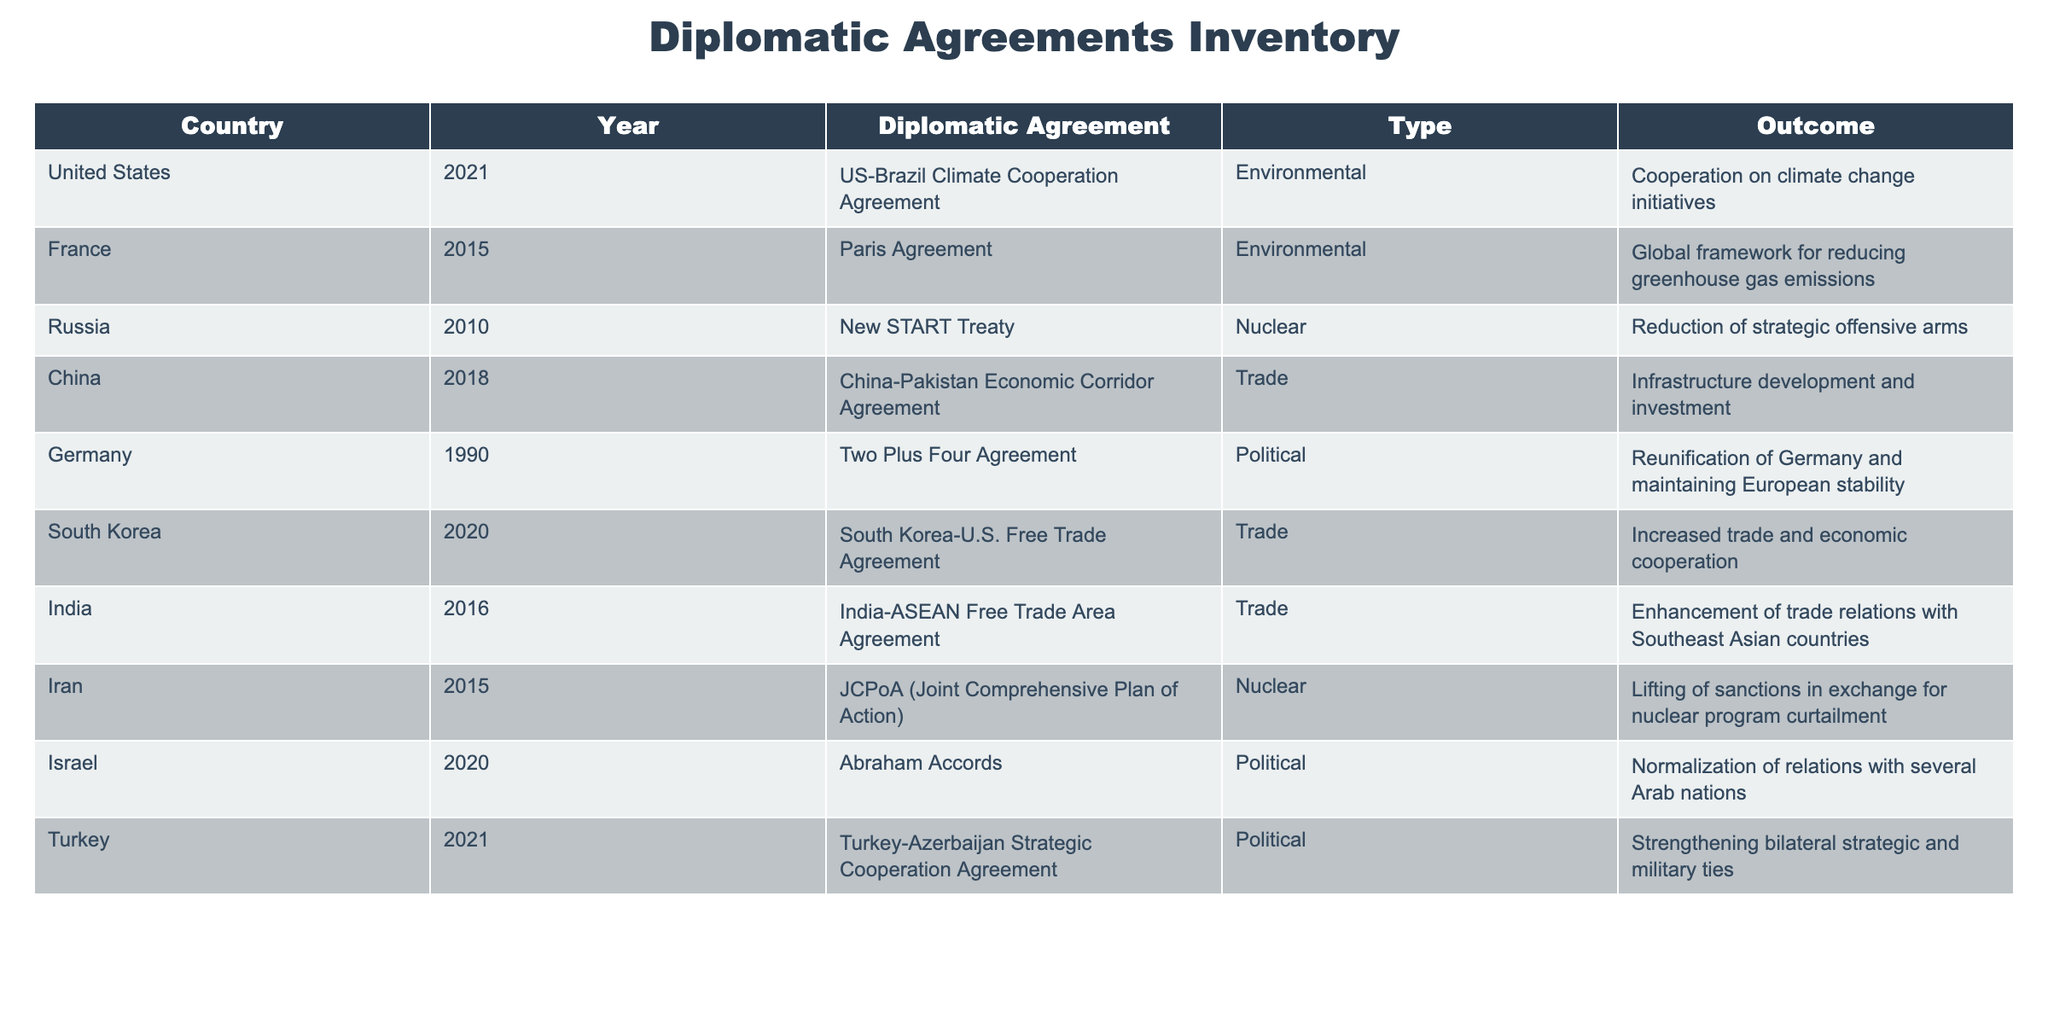What year was the Paris Agreement signed? The Paris Agreement was signed in 2015, as noted in the "Year" column corresponding to "Paris Agreement" listed under "Diplomatic Agreement".
Answer: 2015 Which diplomatic agreement focused on environmental issues and was signed by the United States? The US-Brazil Climate Cooperation Agreement focused on environmental issues and was signed by the United States in 2021.
Answer: US-Brazil Climate Cooperation Agreement How many trade agreements are listed in the table? The table lists three trade agreements: the China-Pakistan Economic Corridor Agreement, South Korea-U.S. Free Trade Agreement, and India-ASEAN Free Trade Area Agreement.
Answer: 3 Did Turkey sign any diplomatic agreement focused on military ties? Yes, Turkey signed the Turkey-Azerbaijan Strategic Cooperation Agreement, which aimed at strengthening bilateral strategic and military ties.
Answer: Yes What was the outcome of the Iran nuclear agreement? The outcome of the JCPoA (Joint Comprehensive Plan of Action) was the lifting of sanctions in exchange for curtailment of Iran's nuclear program, as stated in the outcome column.
Answer: Lifting of sanctions Which country signed a political agreement in 2020 that involved normalization of relations with Arab nations? Israel signed the Abraham Accords in 2020, which involved normalization of relations with several Arab nations.
Answer: Israel How many years elapsed between the two Plus Four Agreement and the New START Treaty? The Two Plus Four Agreement was signed in 1990 and the New START Treaty in 2010. Therefore, 2010 - 1990 = 20 years elapsed between these two agreements.
Answer: 20 years How many nuclear agreements are present in the table? There are two nuclear agreements in the table: the New START Treaty (2010) and the JCPoA (2015).
Answer: 2 Which country had the earliest diplomatic agreement listed in the table? The earliest diplomatic agreement listed is the Two Plus Four Agreement signed by Germany in 1990.
Answer: Germany 